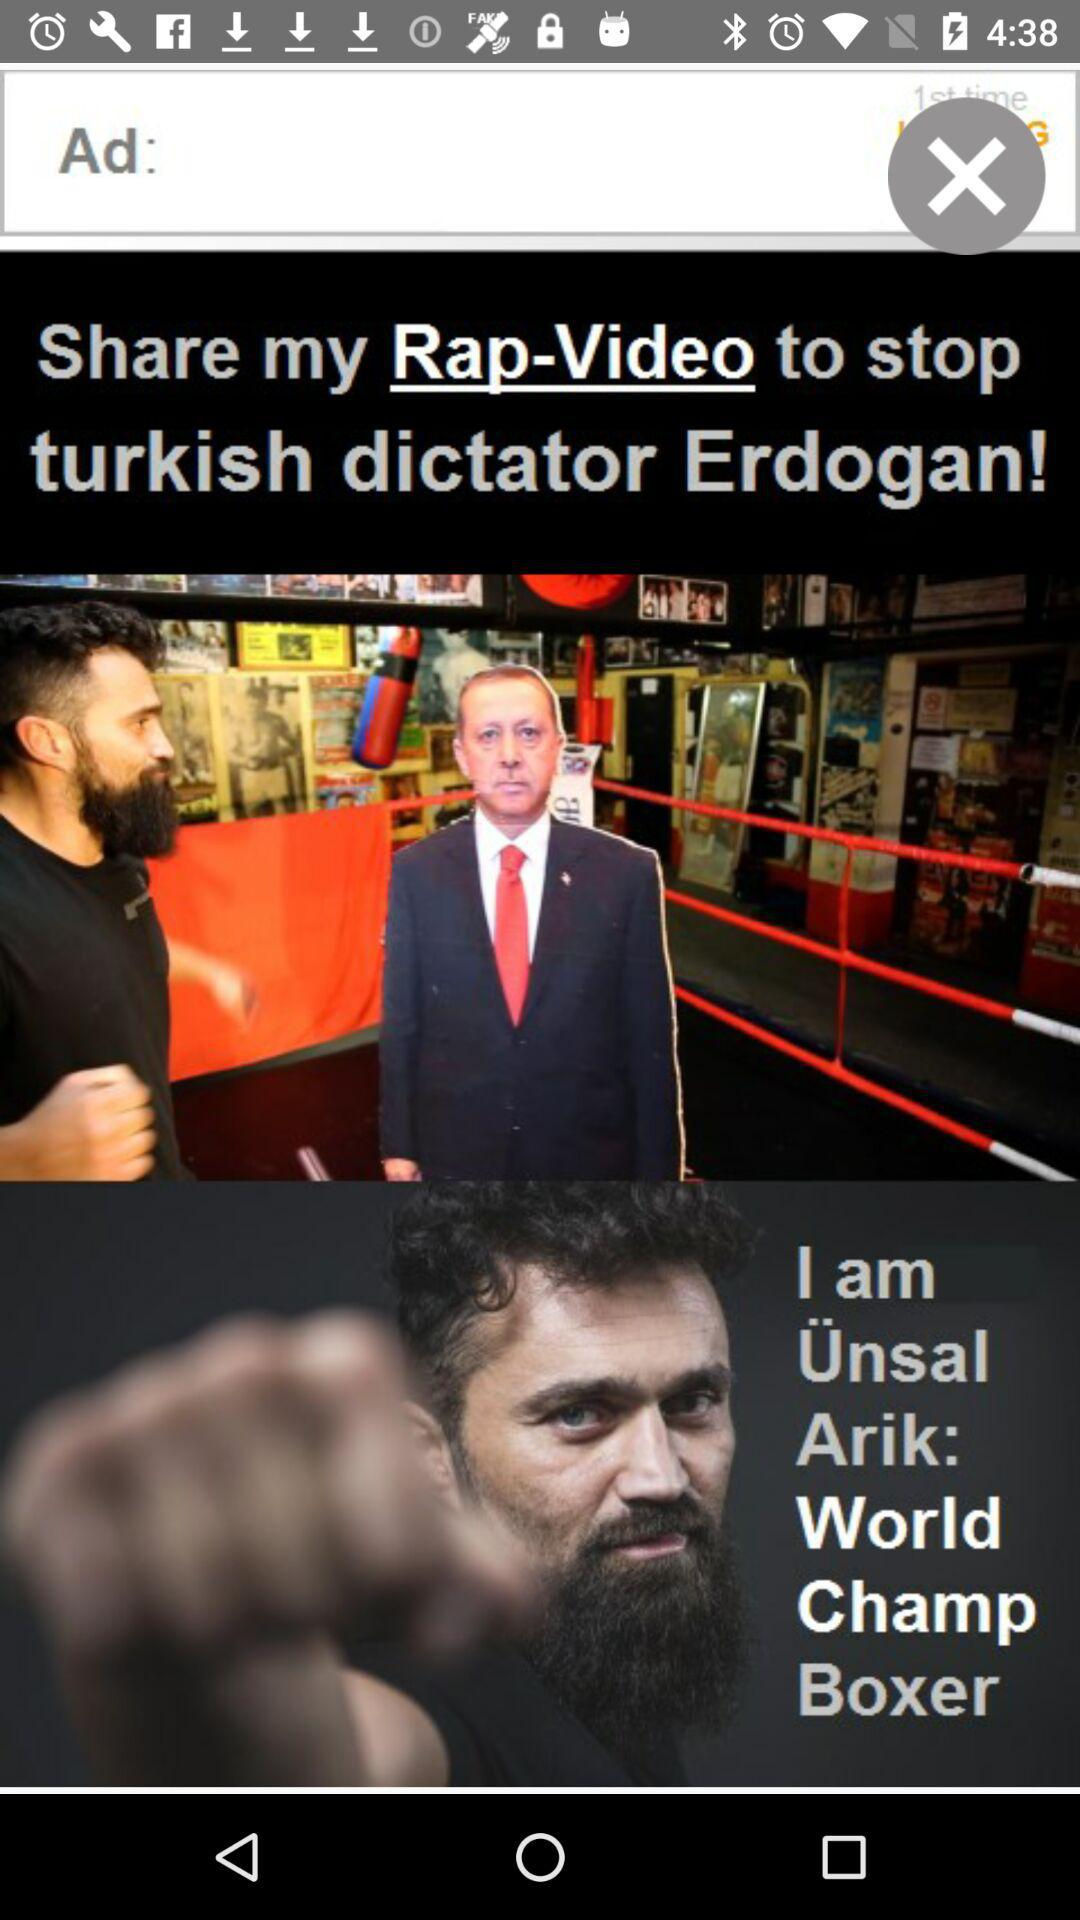Who is Ünsal Arik? Ünsal Arik is a world-champion boxer. 